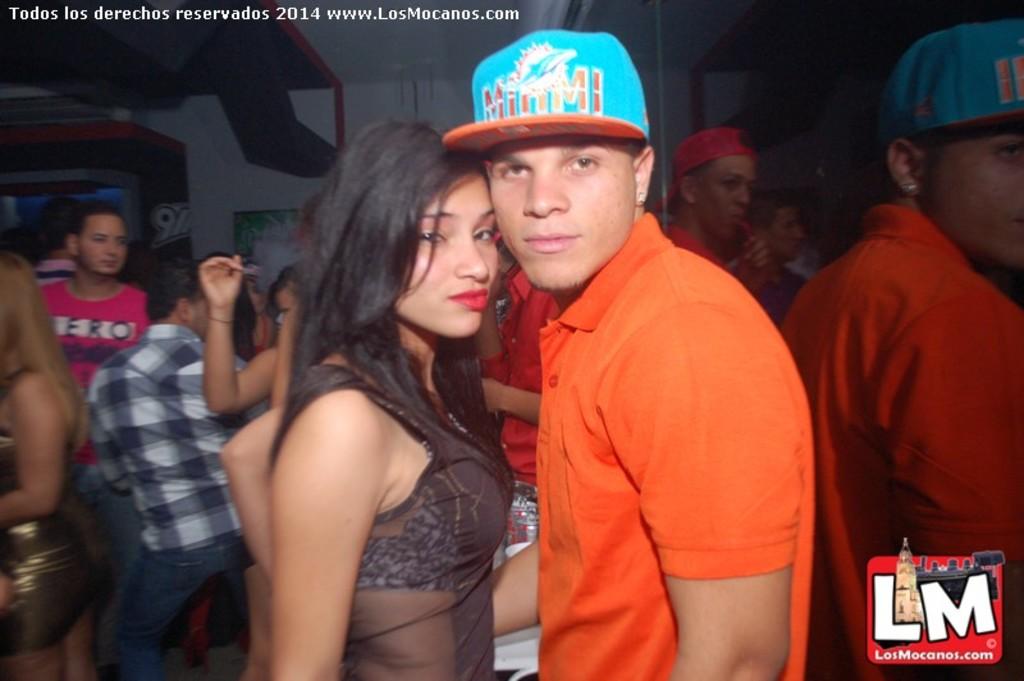What year was this photo taken?
Your response must be concise. 2014. 